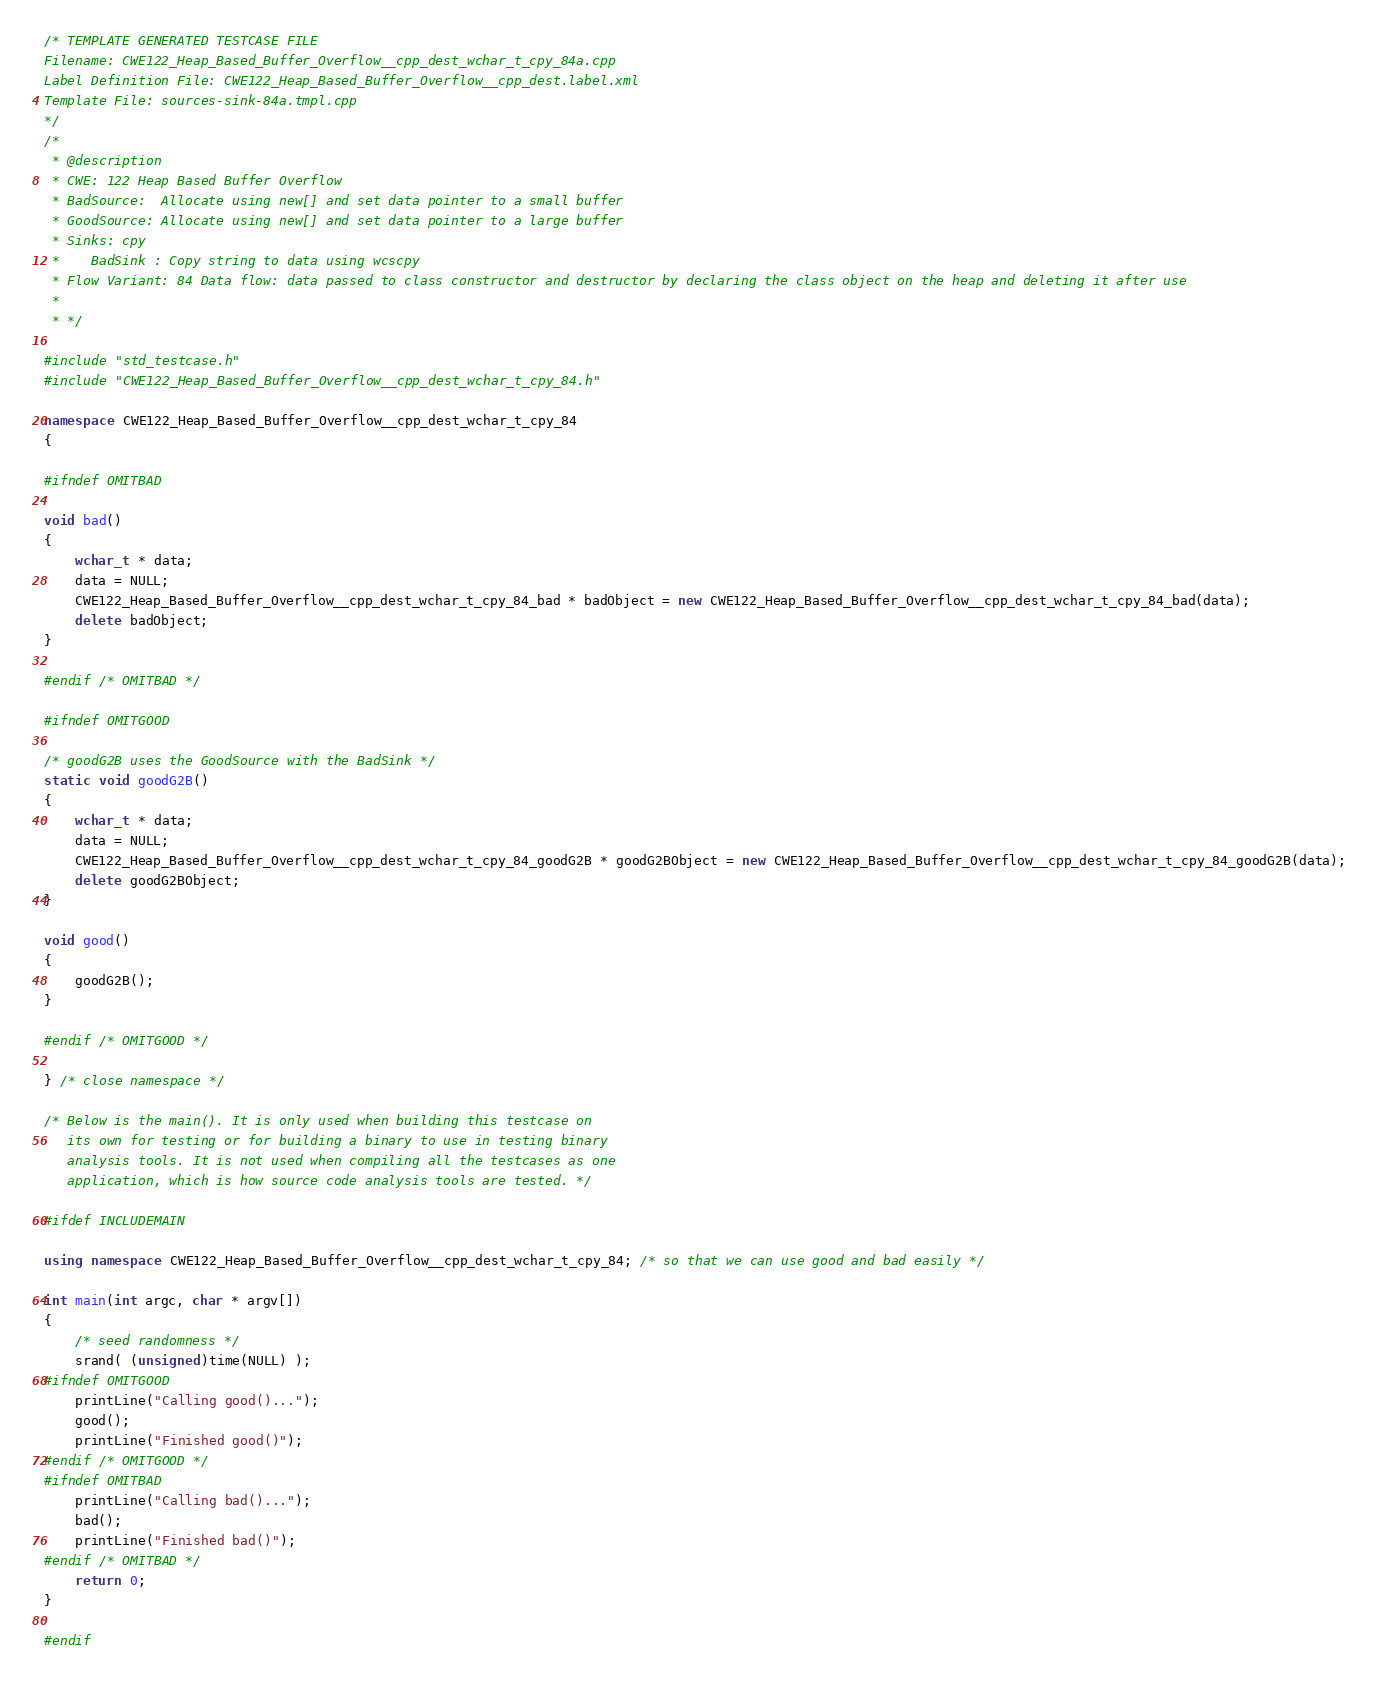Convert code to text. <code><loc_0><loc_0><loc_500><loc_500><_C++_>/* TEMPLATE GENERATED TESTCASE FILE
Filename: CWE122_Heap_Based_Buffer_Overflow__cpp_dest_wchar_t_cpy_84a.cpp
Label Definition File: CWE122_Heap_Based_Buffer_Overflow__cpp_dest.label.xml
Template File: sources-sink-84a.tmpl.cpp
*/
/*
 * @description
 * CWE: 122 Heap Based Buffer Overflow
 * BadSource:  Allocate using new[] and set data pointer to a small buffer
 * GoodSource: Allocate using new[] and set data pointer to a large buffer
 * Sinks: cpy
 *    BadSink : Copy string to data using wcscpy
 * Flow Variant: 84 Data flow: data passed to class constructor and destructor by declaring the class object on the heap and deleting it after use
 *
 * */

#include "std_testcase.h"
#include "CWE122_Heap_Based_Buffer_Overflow__cpp_dest_wchar_t_cpy_84.h"

namespace CWE122_Heap_Based_Buffer_Overflow__cpp_dest_wchar_t_cpy_84
{

#ifndef OMITBAD

void bad()
{
    wchar_t * data;
    data = NULL;
    CWE122_Heap_Based_Buffer_Overflow__cpp_dest_wchar_t_cpy_84_bad * badObject = new CWE122_Heap_Based_Buffer_Overflow__cpp_dest_wchar_t_cpy_84_bad(data);
    delete badObject;
}

#endif /* OMITBAD */

#ifndef OMITGOOD

/* goodG2B uses the GoodSource with the BadSink */
static void goodG2B()
{
    wchar_t * data;
    data = NULL;
    CWE122_Heap_Based_Buffer_Overflow__cpp_dest_wchar_t_cpy_84_goodG2B * goodG2BObject = new CWE122_Heap_Based_Buffer_Overflow__cpp_dest_wchar_t_cpy_84_goodG2B(data);
    delete goodG2BObject;
}

void good()
{
    goodG2B();
}

#endif /* OMITGOOD */

} /* close namespace */

/* Below is the main(). It is only used when building this testcase on
   its own for testing or for building a binary to use in testing binary
   analysis tools. It is not used when compiling all the testcases as one
   application, which is how source code analysis tools are tested. */

#ifdef INCLUDEMAIN

using namespace CWE122_Heap_Based_Buffer_Overflow__cpp_dest_wchar_t_cpy_84; /* so that we can use good and bad easily */

int main(int argc, char * argv[])
{
    /* seed randomness */
    srand( (unsigned)time(NULL) );
#ifndef OMITGOOD
    printLine("Calling good()...");
    good();
    printLine("Finished good()");
#endif /* OMITGOOD */
#ifndef OMITBAD
    printLine("Calling bad()...");
    bad();
    printLine("Finished bad()");
#endif /* OMITBAD */
    return 0;
}

#endif
</code> 